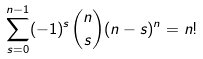Convert formula to latex. <formula><loc_0><loc_0><loc_500><loc_500>\sum _ { s = 0 } ^ { n - 1 } ( - 1 ) ^ { s } { n \choose s } ( n - s ) ^ { n } = n !</formula> 